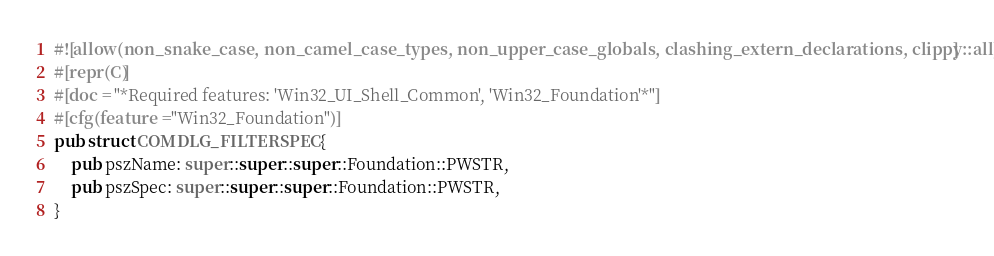Convert code to text. <code><loc_0><loc_0><loc_500><loc_500><_Rust_>#![allow(non_snake_case, non_camel_case_types, non_upper_case_globals, clashing_extern_declarations, clippy::all)]
#[repr(C)]
#[doc = "*Required features: 'Win32_UI_Shell_Common', 'Win32_Foundation'*"]
#[cfg(feature = "Win32_Foundation")]
pub struct COMDLG_FILTERSPEC {
    pub pszName: super::super::super::Foundation::PWSTR,
    pub pszSpec: super::super::super::Foundation::PWSTR,
}</code> 